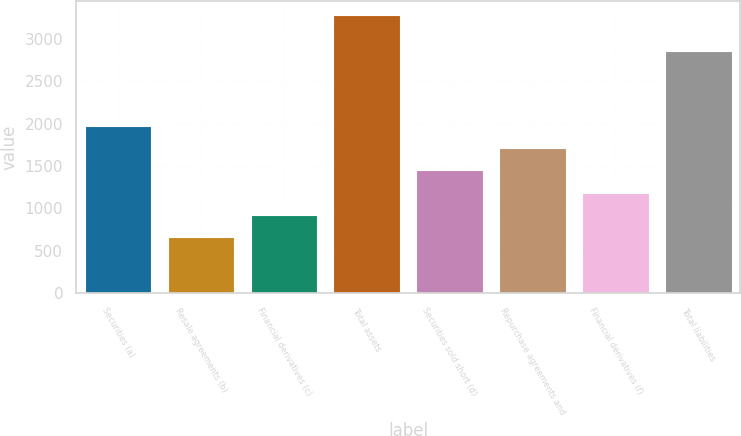Convert chart to OTSL. <chart><loc_0><loc_0><loc_500><loc_500><bar_chart><fcel>Securities (a)<fcel>Resale agreements (b)<fcel>Financial derivatives (c)<fcel>Total assets<fcel>Securities sold short (d)<fcel>Repurchase agreements and<fcel>Financial derivatives (f)<fcel>Total liabilities<nl><fcel>1974<fcel>663<fcel>925.2<fcel>3285<fcel>1449.6<fcel>1711.8<fcel>1187.4<fcel>2862<nl></chart> 